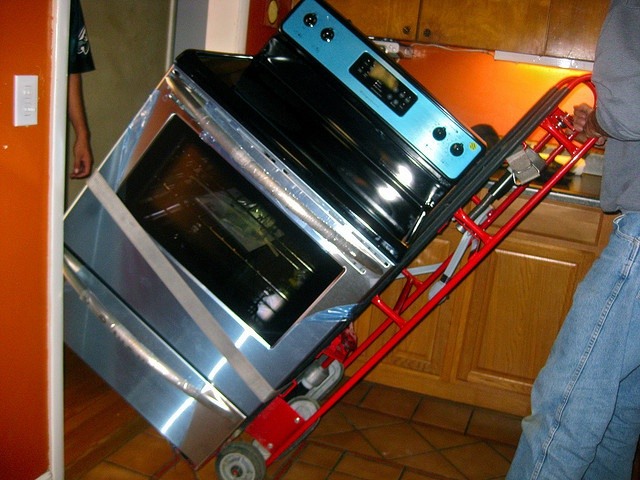Describe the objects in this image and their specific colors. I can see oven in maroon, black, gray, darkgray, and purple tones, people in maroon, gray, and blue tones, and people in maroon, black, and brown tones in this image. 